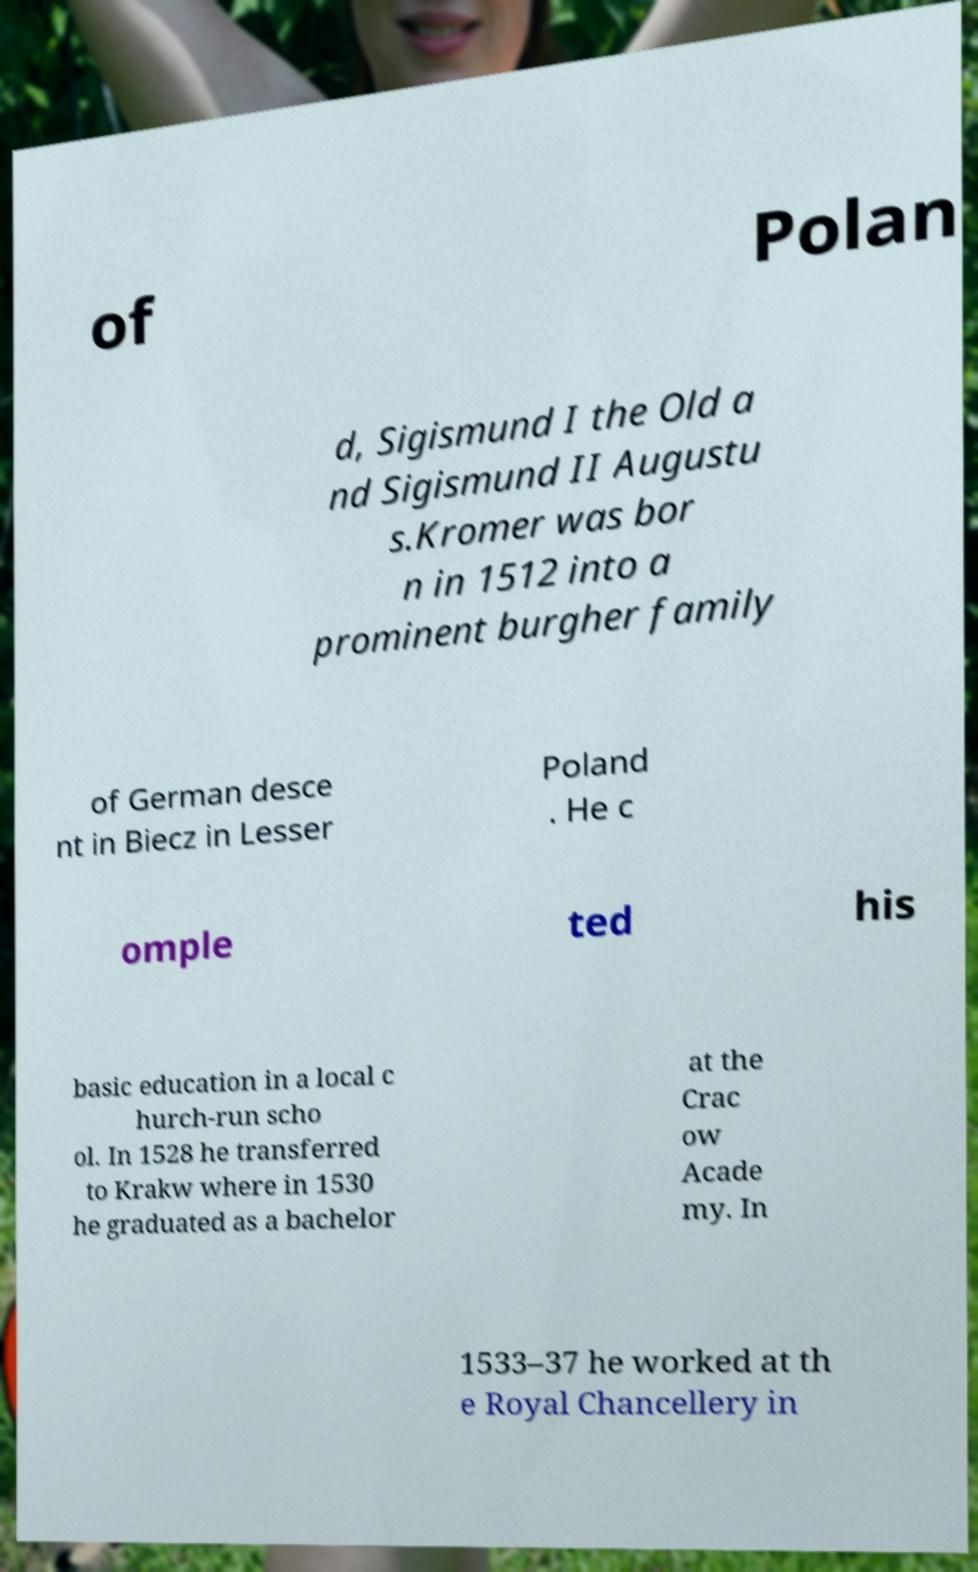For documentation purposes, I need the text within this image transcribed. Could you provide that? of Polan d, Sigismund I the Old a nd Sigismund II Augustu s.Kromer was bor n in 1512 into a prominent burgher family of German desce nt in Biecz in Lesser Poland . He c omple ted his basic education in a local c hurch-run scho ol. In 1528 he transferred to Krakw where in 1530 he graduated as a bachelor at the Crac ow Acade my. In 1533–37 he worked at th e Royal Chancellery in 